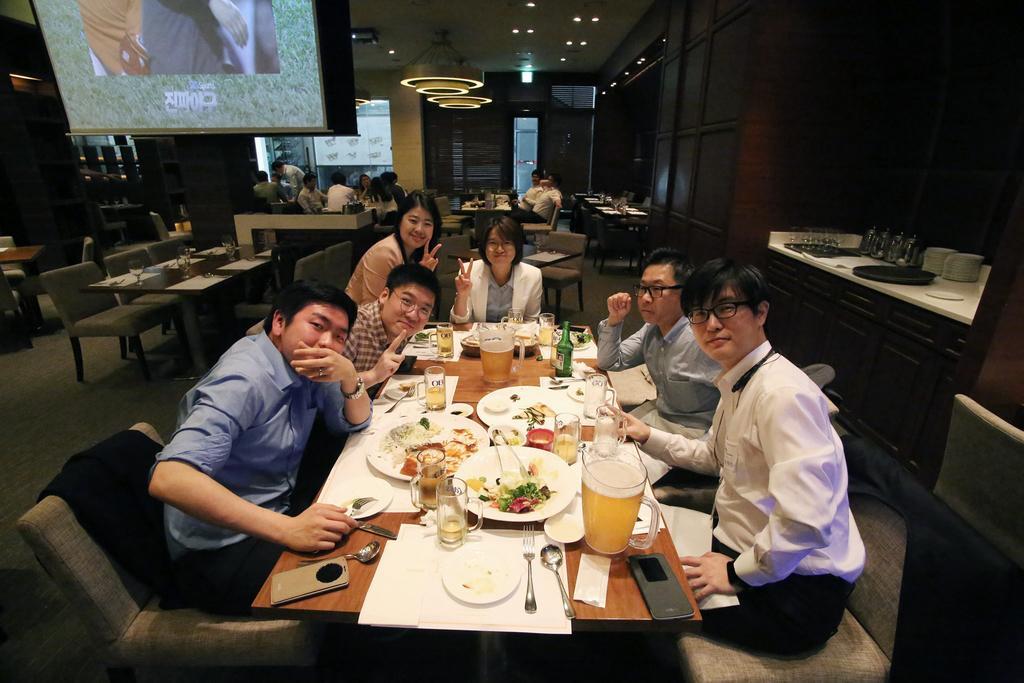Could you give a brief overview of what you see in this image? As we can see in the image there is a banner, tables, chairs, few people here and there and on tables there are tissues, white color clothes, forks, spoons, plates, glasses, bottles and different types of food items. 